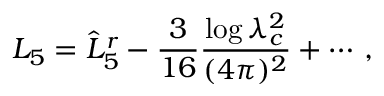<formula> <loc_0><loc_0><loc_500><loc_500>L _ { 5 } = \hat { L } _ { 5 } ^ { r } - \frac { 3 } { 1 6 } \frac { \log \lambda _ { c } ^ { 2 } } { ( 4 \pi ) ^ { 2 } } + \cdots \, ,</formula> 